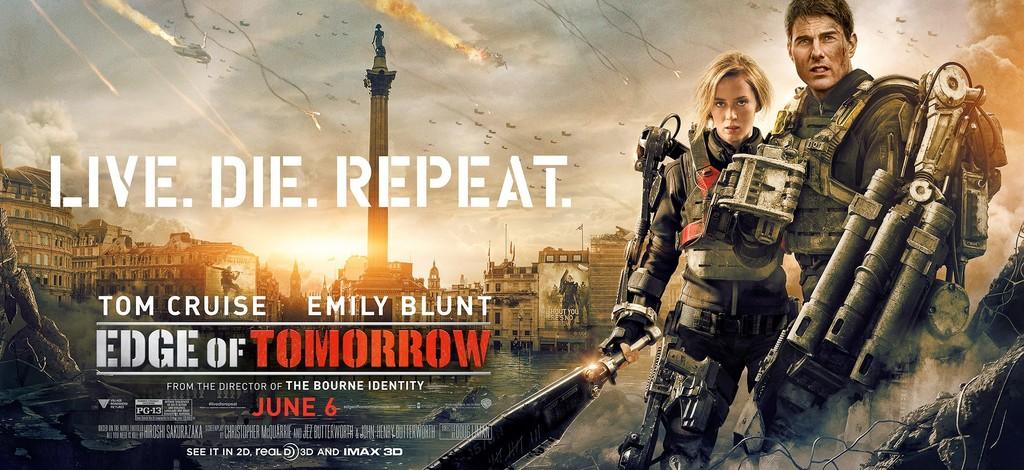When does this movie come out?
Your answer should be very brief. June 6. Who stars in this movie?
Offer a very short reply. Tom cruise and emily blunt. 